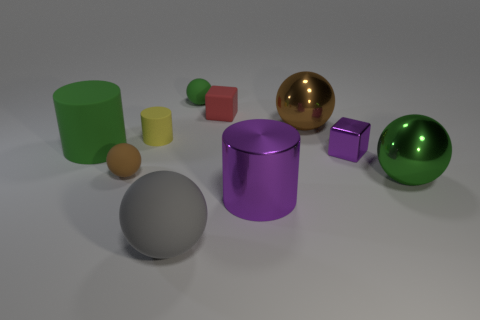The large metal object that is the same color as the tiny shiny object is what shape?
Offer a terse response. Cylinder. There is a green shiny ball; does it have the same size as the matte object that is to the right of the tiny green thing?
Offer a very short reply. No. Are there more green cylinders that are to the left of the small red rubber block than big cyan shiny things?
Offer a very short reply. Yes. There is a yellow object that is the same material as the red object; what is its size?
Your answer should be very brief. Small. Is there a big matte cylinder of the same color as the metal cylinder?
Make the answer very short. No. How many objects are either purple shiny cubes or large things that are to the left of the brown shiny sphere?
Your answer should be compact. 4. Are there more rubber blocks than balls?
Provide a short and direct response. No. The cube that is the same color as the metal cylinder is what size?
Provide a succinct answer. Small. Is there a large gray thing made of the same material as the small yellow object?
Offer a very short reply. Yes. What is the shape of the big object that is in front of the big green metal object and left of the tiny green matte thing?
Your answer should be very brief. Sphere. 